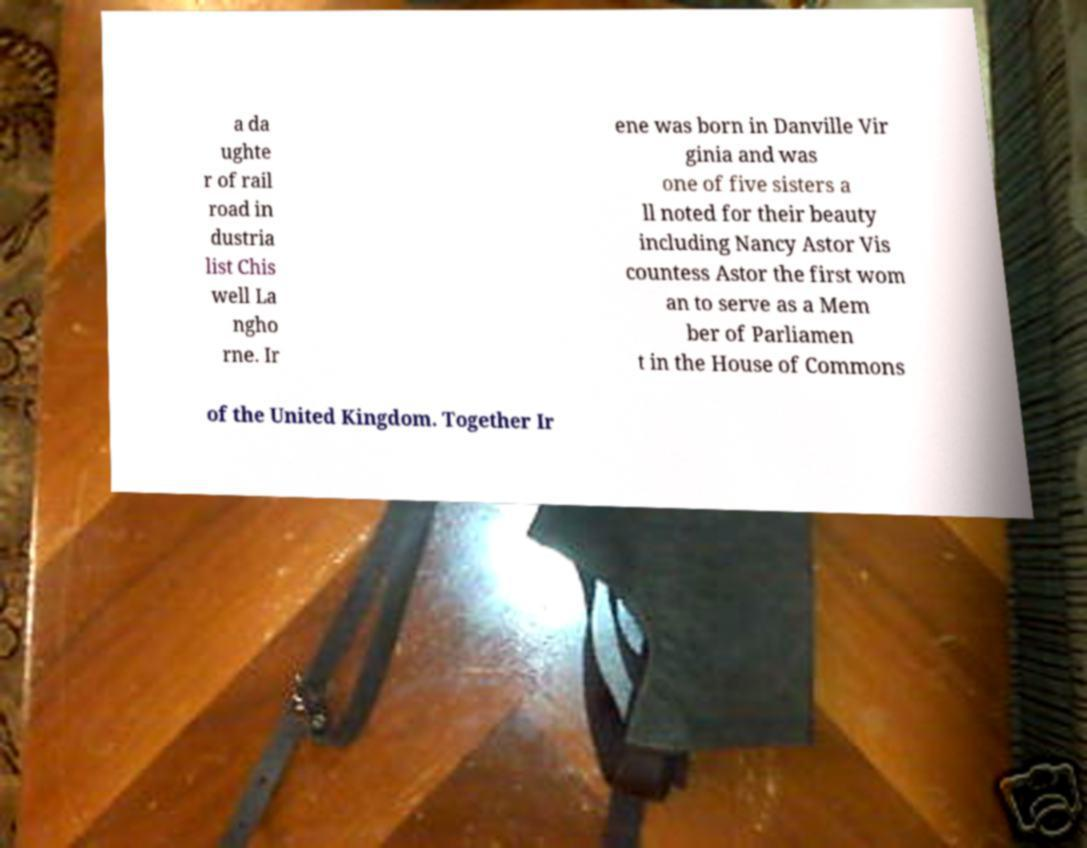Could you assist in decoding the text presented in this image and type it out clearly? a da ughte r of rail road in dustria list Chis well La ngho rne. Ir ene was born in Danville Vir ginia and was one of five sisters a ll noted for their beauty including Nancy Astor Vis countess Astor the first wom an to serve as a Mem ber of Parliamen t in the House of Commons of the United Kingdom. Together Ir 